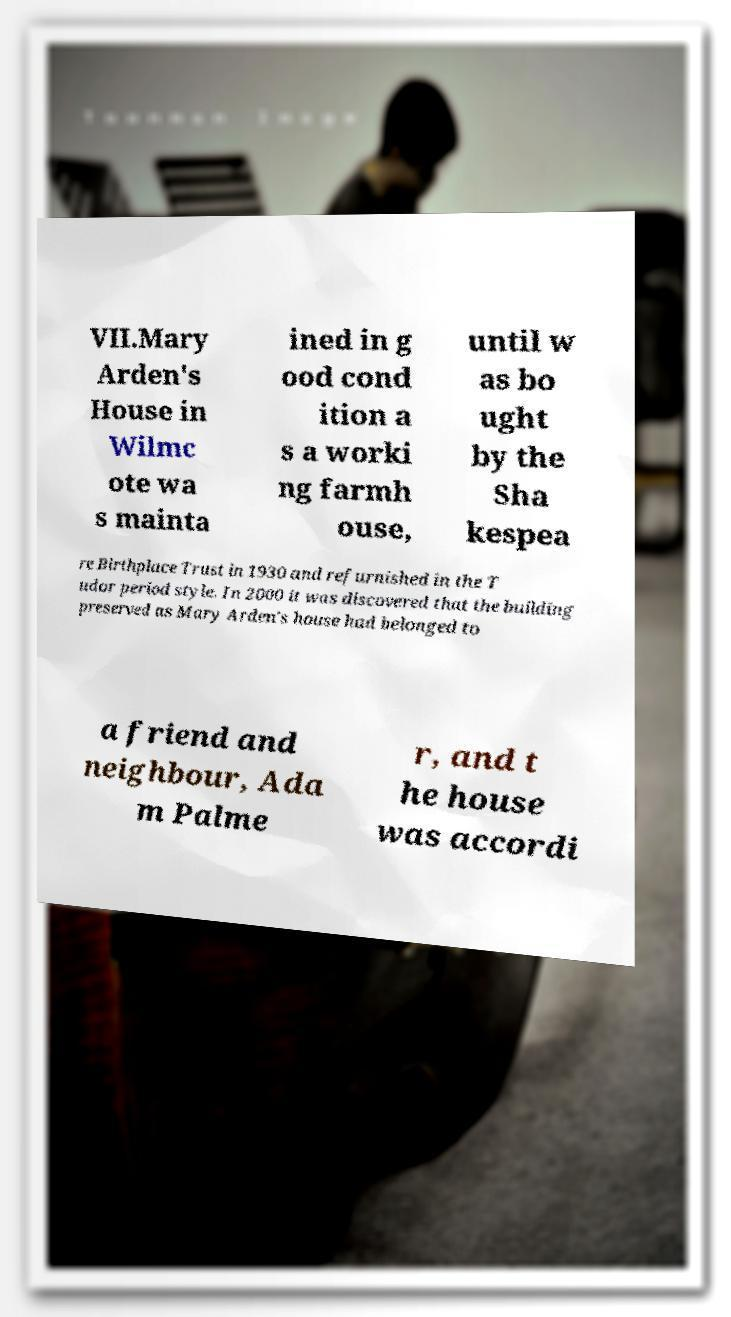Can you read and provide the text displayed in the image?This photo seems to have some interesting text. Can you extract and type it out for me? VII.Mary Arden's House in Wilmc ote wa s mainta ined in g ood cond ition a s a worki ng farmh ouse, until w as bo ught by the Sha kespea re Birthplace Trust in 1930 and refurnished in the T udor period style. In 2000 it was discovered that the building preserved as Mary Arden's house had belonged to a friend and neighbour, Ada m Palme r, and t he house was accordi 